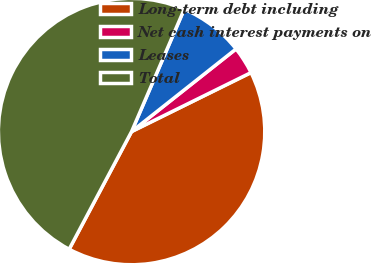Convert chart. <chart><loc_0><loc_0><loc_500><loc_500><pie_chart><fcel>Long-term debt including<fcel>Net cash interest payments on<fcel>Leases<fcel>Total<nl><fcel>40.06%<fcel>3.35%<fcel>7.88%<fcel>48.7%<nl></chart> 